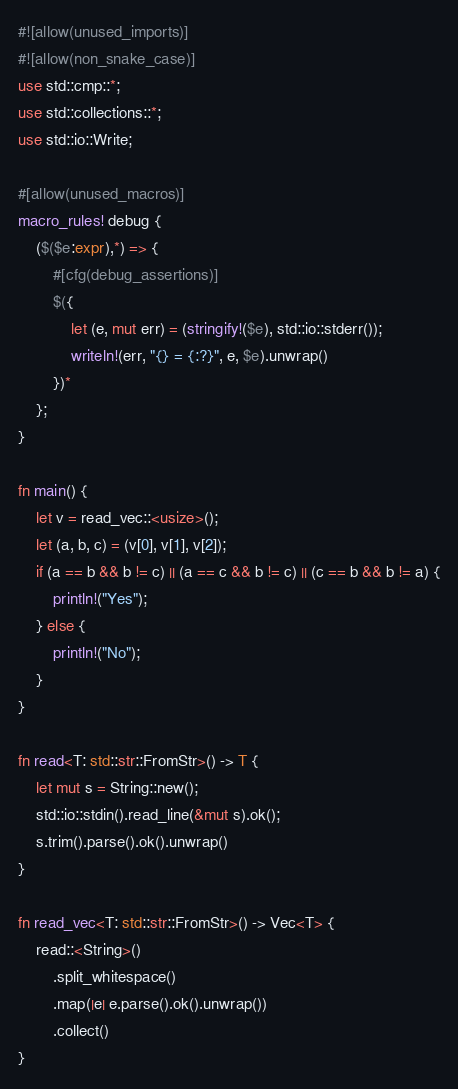<code> <loc_0><loc_0><loc_500><loc_500><_Rust_>#![allow(unused_imports)]
#![allow(non_snake_case)]
use std::cmp::*;
use std::collections::*;
use std::io::Write;

#[allow(unused_macros)]
macro_rules! debug {
    ($($e:expr),*) => {
        #[cfg(debug_assertions)]
        $({
            let (e, mut err) = (stringify!($e), std::io::stderr());
            writeln!(err, "{} = {:?}", e, $e).unwrap()
        })*
    };
}

fn main() {
    let v = read_vec::<usize>();
    let (a, b, c) = (v[0], v[1], v[2]);
    if (a == b && b != c) || (a == c && b != c) || (c == b && b != a) {
        println!("Yes");
    } else {
        println!("No");
    }
}

fn read<T: std::str::FromStr>() -> T {
    let mut s = String::new();
    std::io::stdin().read_line(&mut s).ok();
    s.trim().parse().ok().unwrap()
}

fn read_vec<T: std::str::FromStr>() -> Vec<T> {
    read::<String>()
        .split_whitespace()
        .map(|e| e.parse().ok().unwrap())
        .collect()
}
</code> 